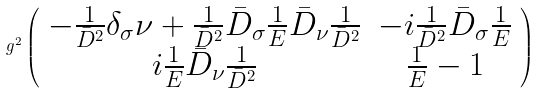<formula> <loc_0><loc_0><loc_500><loc_500>g ^ { 2 } \left ( \begin{array} { c c } { { - \frac { 1 } { \bar { D } ^ { 2 } } \delta _ { \sigma } \nu + \frac { 1 } { \bar { D } ^ { 2 } } \bar { D } _ { \sigma } \frac { 1 } { E } \bar { D } _ { \nu } \frac { 1 } { \bar { D } ^ { 2 } } } } & { { - i \frac { 1 } { \bar { D } ^ { 2 } } \bar { D } _ { \sigma } \frac { 1 } { E } } } \\ { { i \frac { 1 } { E } \bar { D } _ { \nu } \frac { 1 } { \bar { D } ^ { 2 } } } } & { { \frac { 1 } { E } - 1 } } \end{array} \right )</formula> 